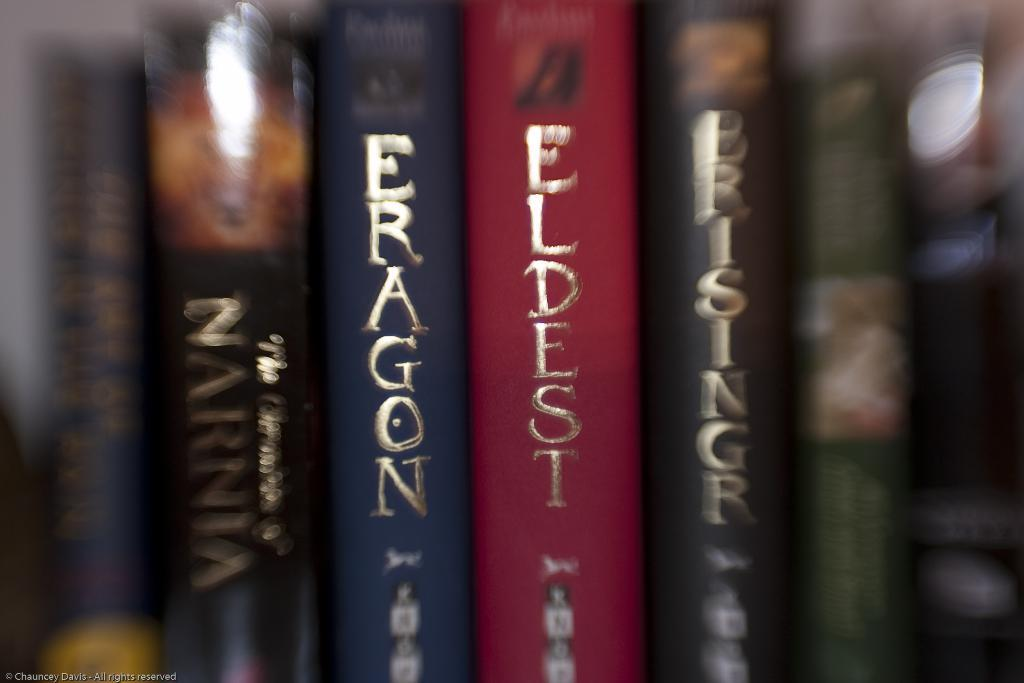What is present in the image that is related to reading or learning? There is a group of books in the image. What can be found on the surface of the books? The books have text on them. How many tickets are visible in the image? There are no tickets present in the image; it only features a group of books with text on them. 